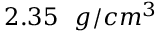<formula> <loc_0><loc_0><loc_500><loc_500>2 . 3 5 \ \ g / c m ^ { 3 }</formula> 